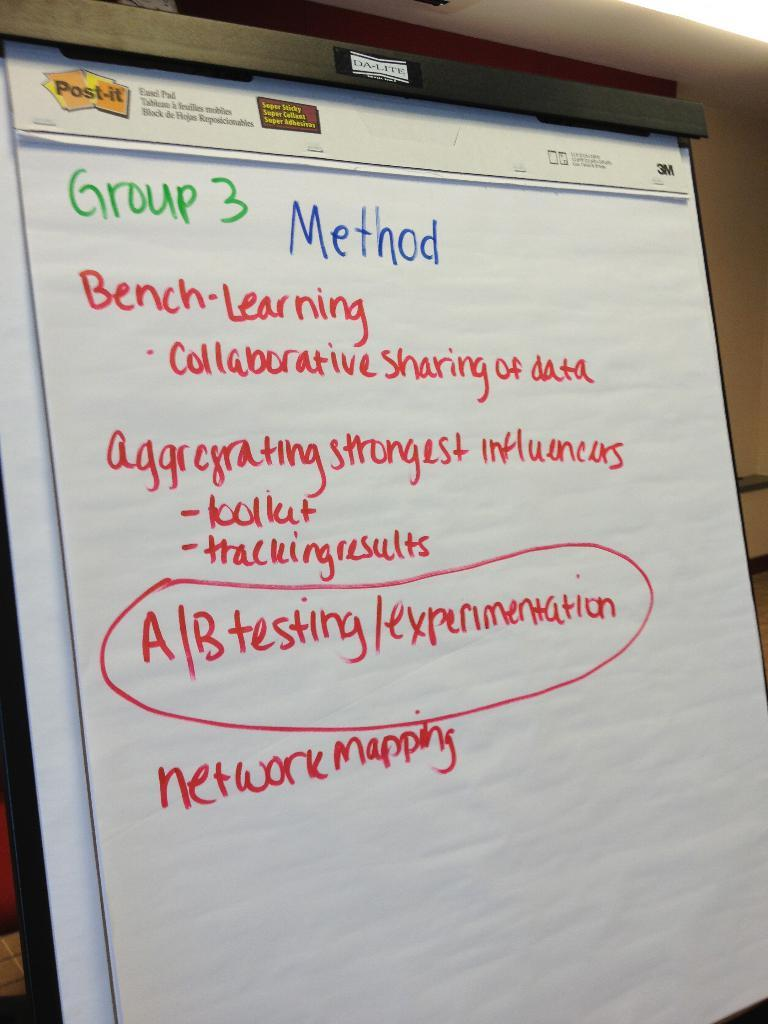<image>
Write a terse but informative summary of the picture. A white paper board with marketing methods written on it 